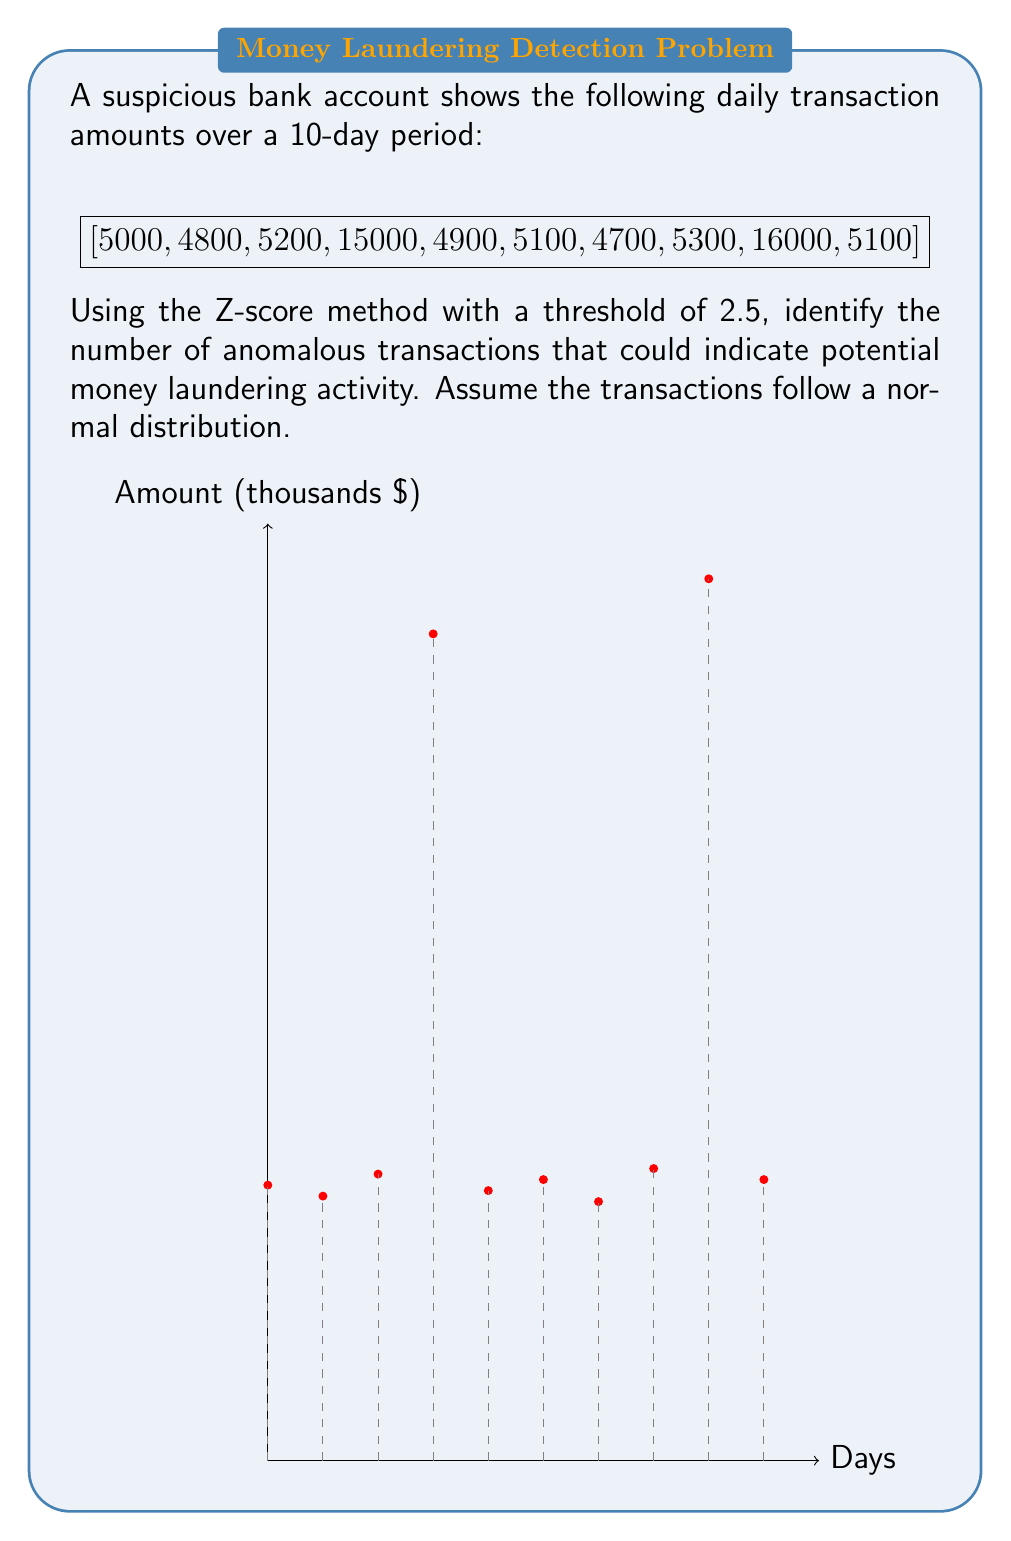Could you help me with this problem? To solve this problem, we'll follow these steps:

1) Calculate the mean (μ) of the transactions:
   $$\mu = \frac{5000 + 4800 + 5200 + 15000 + 4900 + 5100 + 4700 + 5300 + 16000 + 5100}{10} = 7110$$

2) Calculate the standard deviation (σ):
   $$\sigma = \sqrt{\frac{\sum_{i=1}^{n} (x_i - \mu)^2}{n}}$$
   
   $$\sigma = \sqrt{\frac{(5000-7110)^2 + (4800-7110)^2 + ... + (5100-7110)^2}{10}} \approx 4372.77$$

3) Calculate the Z-score for each transaction:
   $$Z = \frac{x - \mu}{\sigma}$$

   For example, for the first transaction:
   $$Z_1 = \frac{5000 - 7110}{4372.77} \approx -0.48$$

4) Identify transactions with |Z| > 2.5:

   Day 1: Z ≈ -0.48
   Day 2: Z ≈ -0.53
   Day 3: Z ≈ -0.44
   Day 4: Z ≈ 1.80
   Day 5: Z ≈ -0.51
   Day 6: Z ≈ -0.46
   Day 7: Z ≈ -0.55
   Day 8: Z ≈ -0.41
   Day 9: Z ≈ 2.03
   Day 10: Z ≈ -0.46

5) Count the number of transactions where |Z| > 2.5.

None of the transactions have a Z-score with an absolute value greater than 2.5.
Answer: 0 